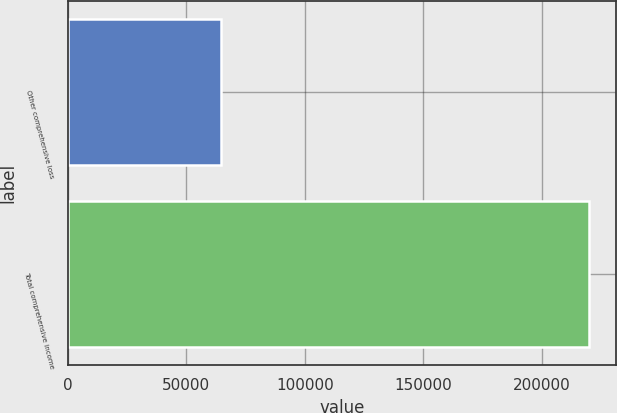Convert chart. <chart><loc_0><loc_0><loc_500><loc_500><bar_chart><fcel>Other comprehensive loss<fcel>Total comprehensive income<nl><fcel>64471<fcel>220030<nl></chart> 